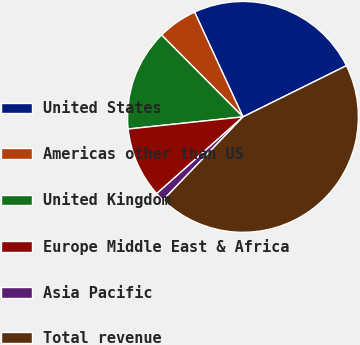Convert chart to OTSL. <chart><loc_0><loc_0><loc_500><loc_500><pie_chart><fcel>United States<fcel>Americas other than US<fcel>United Kingdom<fcel>Europe Middle East & Africa<fcel>Asia Pacific<fcel>Total revenue<nl><fcel>24.57%<fcel>5.57%<fcel>14.22%<fcel>9.9%<fcel>1.25%<fcel>44.49%<nl></chart> 